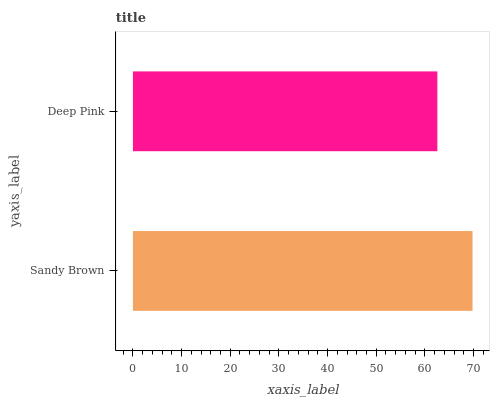Is Deep Pink the minimum?
Answer yes or no. Yes. Is Sandy Brown the maximum?
Answer yes or no. Yes. Is Deep Pink the maximum?
Answer yes or no. No. Is Sandy Brown greater than Deep Pink?
Answer yes or no. Yes. Is Deep Pink less than Sandy Brown?
Answer yes or no. Yes. Is Deep Pink greater than Sandy Brown?
Answer yes or no. No. Is Sandy Brown less than Deep Pink?
Answer yes or no. No. Is Sandy Brown the high median?
Answer yes or no. Yes. Is Deep Pink the low median?
Answer yes or no. Yes. Is Deep Pink the high median?
Answer yes or no. No. Is Sandy Brown the low median?
Answer yes or no. No. 